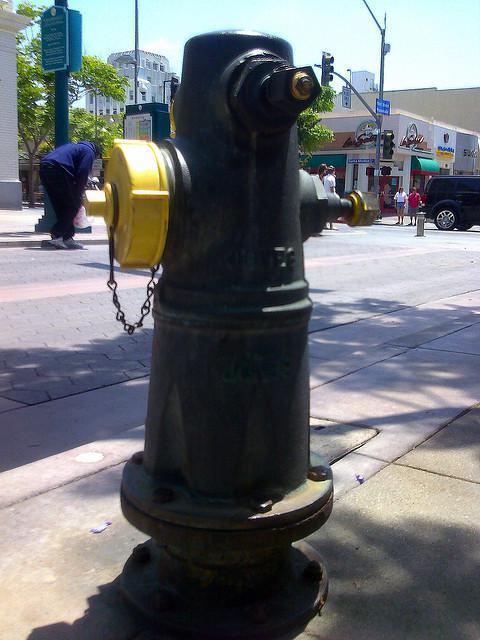How many dog can you see in the image?
Give a very brief answer. 0. 